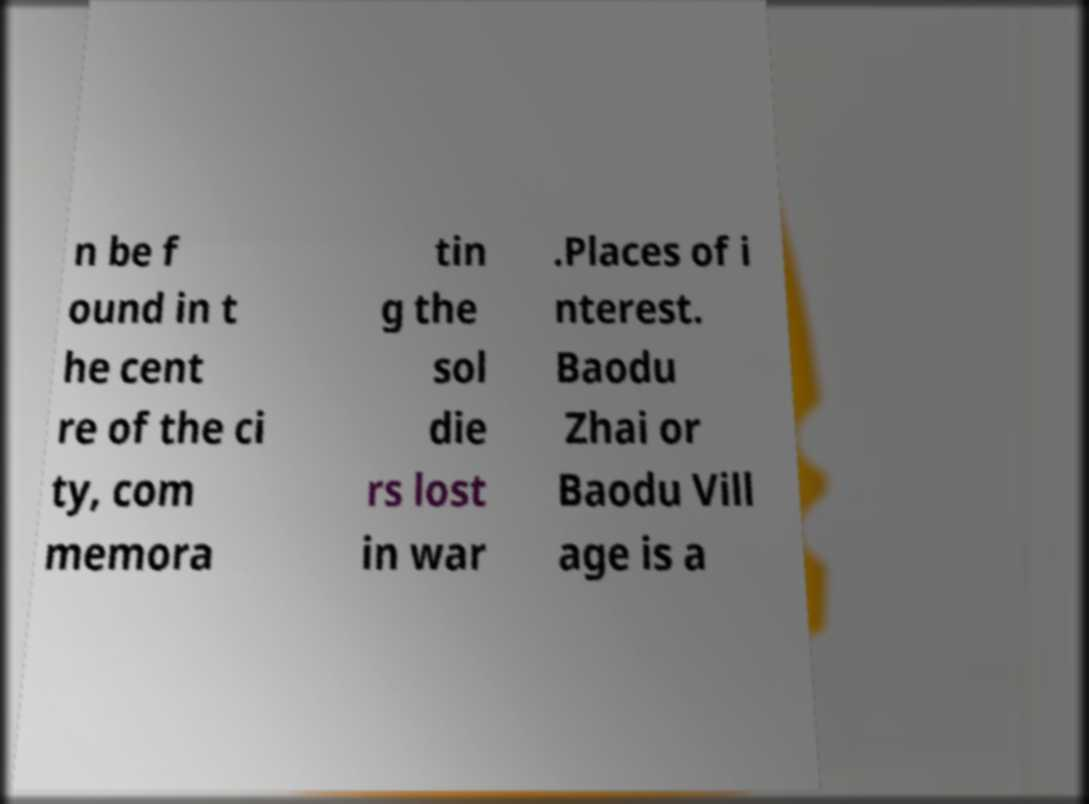Could you extract and type out the text from this image? n be f ound in t he cent re of the ci ty, com memora tin g the sol die rs lost in war .Places of i nterest. Baodu Zhai or Baodu Vill age is a 